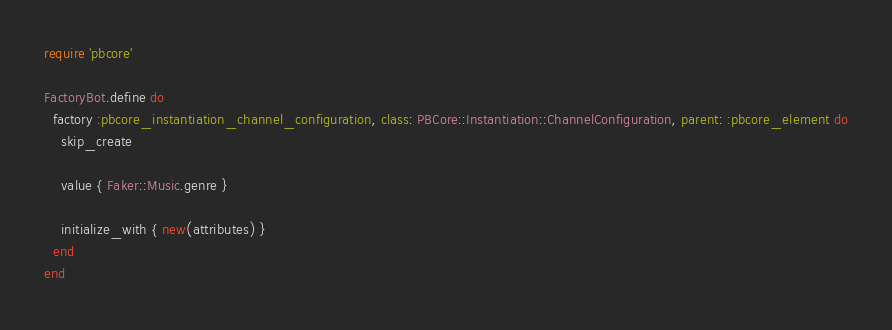Convert code to text. <code><loc_0><loc_0><loc_500><loc_500><_Ruby_>require 'pbcore'

FactoryBot.define do
  factory :pbcore_instantiation_channel_configuration, class: PBCore::Instantiation::ChannelConfiguration, parent: :pbcore_element do
    skip_create

    value { Faker::Music.genre }

    initialize_with { new(attributes) }
  end
end</code> 